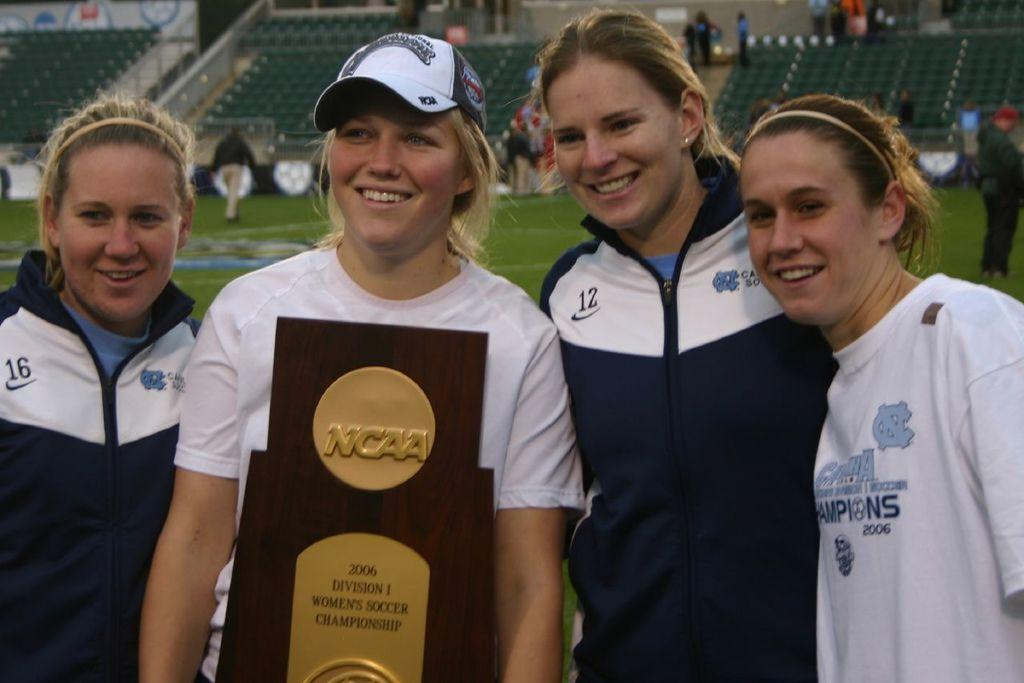What are the women in the middle of the image doing? The women are standing in the middle of the image and smiling. What is one of the women holding? One of the women is holding a cup. What can be observed about the people behind the women? There are people walking and standing behind the women. What is the background of the image? A stadium is visible in the image. What type of produce is being bitten by a snake in the image? There is no produce or snake present in the image. 